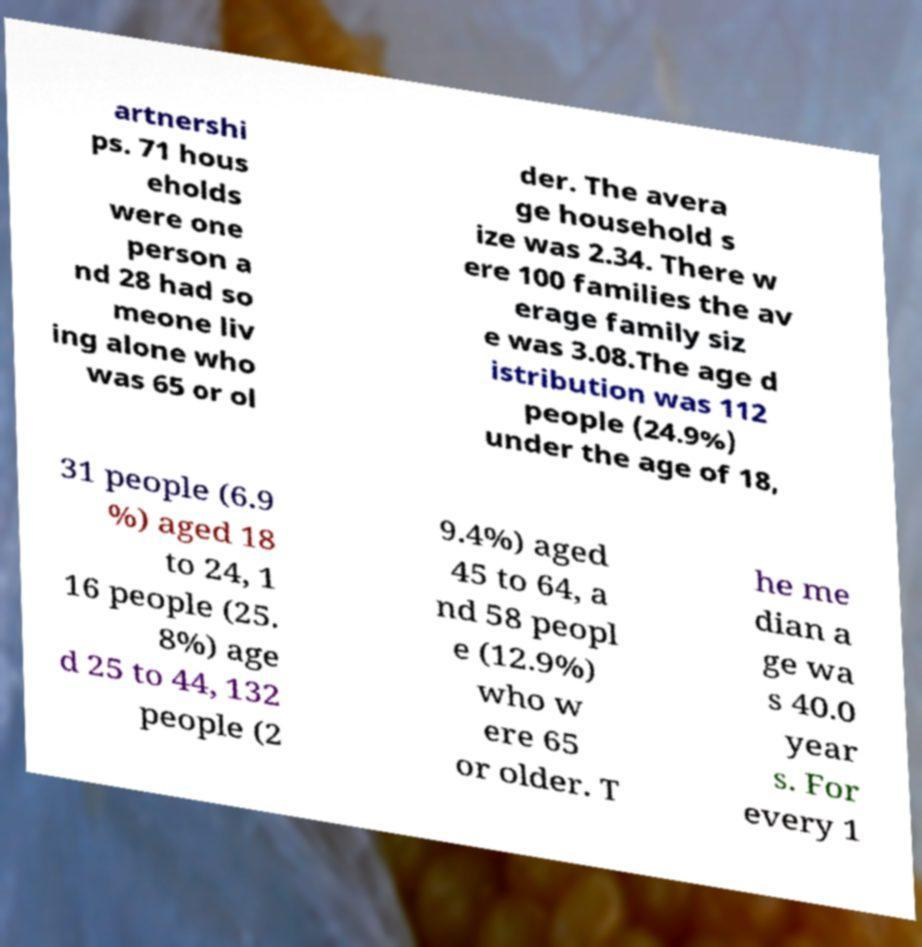Please read and relay the text visible in this image. What does it say? artnershi ps. 71 hous eholds were one person a nd 28 had so meone liv ing alone who was 65 or ol der. The avera ge household s ize was 2.34. There w ere 100 families the av erage family siz e was 3.08.The age d istribution was 112 people (24.9%) under the age of 18, 31 people (6.9 %) aged 18 to 24, 1 16 people (25. 8%) age d 25 to 44, 132 people (2 9.4%) aged 45 to 64, a nd 58 peopl e (12.9%) who w ere 65 or older. T he me dian a ge wa s 40.0 year s. For every 1 